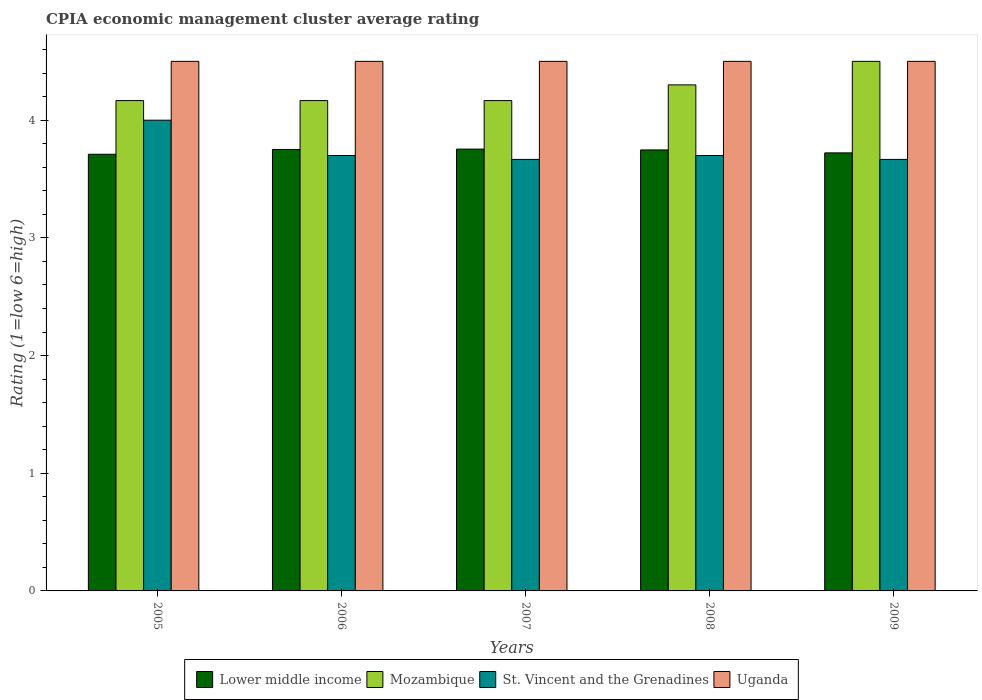How many groups of bars are there?
Your response must be concise. 5. Are the number of bars per tick equal to the number of legend labels?
Offer a terse response. Yes. How many bars are there on the 5th tick from the left?
Give a very brief answer. 4. How many bars are there on the 2nd tick from the right?
Provide a short and direct response. 4. In how many cases, is the number of bars for a given year not equal to the number of legend labels?
Make the answer very short. 0. What is the CPIA rating in Lower middle income in 2008?
Provide a succinct answer. 3.75. Across all years, what is the minimum CPIA rating in Mozambique?
Provide a succinct answer. 4.17. In which year was the CPIA rating in Mozambique maximum?
Give a very brief answer. 2009. In which year was the CPIA rating in St. Vincent and the Grenadines minimum?
Give a very brief answer. 2007. What is the total CPIA rating in St. Vincent and the Grenadines in the graph?
Provide a short and direct response. 18.73. What is the difference between the CPIA rating in Uganda in 2008 and that in 2009?
Provide a succinct answer. 0. What is the difference between the CPIA rating in St. Vincent and the Grenadines in 2008 and the CPIA rating in Mozambique in 2007?
Your response must be concise. -0.47. What is the average CPIA rating in St. Vincent and the Grenadines per year?
Provide a succinct answer. 3.75. In the year 2009, what is the difference between the CPIA rating in Lower middle income and CPIA rating in Mozambique?
Your answer should be very brief. -0.78. In how many years, is the CPIA rating in Uganda greater than 4.2?
Your answer should be compact. 5. What is the ratio of the CPIA rating in St. Vincent and the Grenadines in 2005 to that in 2006?
Give a very brief answer. 1.08. What is the difference between the highest and the second highest CPIA rating in St. Vincent and the Grenadines?
Offer a very short reply. 0.3. What is the difference between the highest and the lowest CPIA rating in St. Vincent and the Grenadines?
Your answer should be very brief. 0.33. In how many years, is the CPIA rating in Lower middle income greater than the average CPIA rating in Lower middle income taken over all years?
Keep it short and to the point. 3. Is the sum of the CPIA rating in St. Vincent and the Grenadines in 2007 and 2008 greater than the maximum CPIA rating in Uganda across all years?
Your answer should be compact. Yes. Is it the case that in every year, the sum of the CPIA rating in St. Vincent and the Grenadines and CPIA rating in Mozambique is greater than the sum of CPIA rating in Lower middle income and CPIA rating in Uganda?
Offer a very short reply. No. What does the 2nd bar from the left in 2007 represents?
Your answer should be very brief. Mozambique. What does the 4th bar from the right in 2008 represents?
Make the answer very short. Lower middle income. Are all the bars in the graph horizontal?
Offer a very short reply. No. What is the difference between two consecutive major ticks on the Y-axis?
Your answer should be very brief. 1. Does the graph contain any zero values?
Make the answer very short. No. How many legend labels are there?
Your answer should be very brief. 4. What is the title of the graph?
Ensure brevity in your answer.  CPIA economic management cluster average rating. What is the label or title of the Y-axis?
Offer a terse response. Rating (1=low 6=high). What is the Rating (1=low 6=high) in Lower middle income in 2005?
Your answer should be compact. 3.71. What is the Rating (1=low 6=high) of Mozambique in 2005?
Your response must be concise. 4.17. What is the Rating (1=low 6=high) of Uganda in 2005?
Give a very brief answer. 4.5. What is the Rating (1=low 6=high) of Lower middle income in 2006?
Your response must be concise. 3.75. What is the Rating (1=low 6=high) of Mozambique in 2006?
Give a very brief answer. 4.17. What is the Rating (1=low 6=high) of Lower middle income in 2007?
Provide a short and direct response. 3.75. What is the Rating (1=low 6=high) in Mozambique in 2007?
Make the answer very short. 4.17. What is the Rating (1=low 6=high) in St. Vincent and the Grenadines in 2007?
Offer a terse response. 3.67. What is the Rating (1=low 6=high) in Lower middle income in 2008?
Offer a terse response. 3.75. What is the Rating (1=low 6=high) in Lower middle income in 2009?
Provide a short and direct response. 3.72. What is the Rating (1=low 6=high) in Mozambique in 2009?
Your answer should be compact. 4.5. What is the Rating (1=low 6=high) in St. Vincent and the Grenadines in 2009?
Offer a very short reply. 3.67. What is the Rating (1=low 6=high) of Uganda in 2009?
Keep it short and to the point. 4.5. Across all years, what is the maximum Rating (1=low 6=high) in Lower middle income?
Make the answer very short. 3.75. Across all years, what is the maximum Rating (1=low 6=high) of St. Vincent and the Grenadines?
Your response must be concise. 4. Across all years, what is the maximum Rating (1=low 6=high) of Uganda?
Provide a succinct answer. 4.5. Across all years, what is the minimum Rating (1=low 6=high) of Lower middle income?
Ensure brevity in your answer.  3.71. Across all years, what is the minimum Rating (1=low 6=high) in Mozambique?
Offer a very short reply. 4.17. Across all years, what is the minimum Rating (1=low 6=high) of St. Vincent and the Grenadines?
Offer a very short reply. 3.67. Across all years, what is the minimum Rating (1=low 6=high) in Uganda?
Your answer should be compact. 4.5. What is the total Rating (1=low 6=high) of Lower middle income in the graph?
Provide a succinct answer. 18.69. What is the total Rating (1=low 6=high) in Mozambique in the graph?
Your answer should be very brief. 21.3. What is the total Rating (1=low 6=high) of St. Vincent and the Grenadines in the graph?
Your answer should be very brief. 18.73. What is the total Rating (1=low 6=high) in Uganda in the graph?
Provide a succinct answer. 22.5. What is the difference between the Rating (1=low 6=high) of Lower middle income in 2005 and that in 2006?
Ensure brevity in your answer.  -0.04. What is the difference between the Rating (1=low 6=high) in St. Vincent and the Grenadines in 2005 and that in 2006?
Your response must be concise. 0.3. What is the difference between the Rating (1=low 6=high) in Uganda in 2005 and that in 2006?
Offer a very short reply. 0. What is the difference between the Rating (1=low 6=high) of Lower middle income in 2005 and that in 2007?
Make the answer very short. -0.04. What is the difference between the Rating (1=low 6=high) of Uganda in 2005 and that in 2007?
Provide a short and direct response. 0. What is the difference between the Rating (1=low 6=high) in Lower middle income in 2005 and that in 2008?
Keep it short and to the point. -0.04. What is the difference between the Rating (1=low 6=high) in Mozambique in 2005 and that in 2008?
Your response must be concise. -0.13. What is the difference between the Rating (1=low 6=high) of St. Vincent and the Grenadines in 2005 and that in 2008?
Provide a short and direct response. 0.3. What is the difference between the Rating (1=low 6=high) in Uganda in 2005 and that in 2008?
Your response must be concise. 0. What is the difference between the Rating (1=low 6=high) in Lower middle income in 2005 and that in 2009?
Your answer should be very brief. -0.01. What is the difference between the Rating (1=low 6=high) in Mozambique in 2005 and that in 2009?
Give a very brief answer. -0.33. What is the difference between the Rating (1=low 6=high) in St. Vincent and the Grenadines in 2005 and that in 2009?
Provide a succinct answer. 0.33. What is the difference between the Rating (1=low 6=high) in Lower middle income in 2006 and that in 2007?
Make the answer very short. -0. What is the difference between the Rating (1=low 6=high) in Mozambique in 2006 and that in 2007?
Your response must be concise. 0. What is the difference between the Rating (1=low 6=high) of St. Vincent and the Grenadines in 2006 and that in 2007?
Provide a short and direct response. 0.03. What is the difference between the Rating (1=low 6=high) of Lower middle income in 2006 and that in 2008?
Offer a very short reply. 0. What is the difference between the Rating (1=low 6=high) of Mozambique in 2006 and that in 2008?
Offer a very short reply. -0.13. What is the difference between the Rating (1=low 6=high) of Uganda in 2006 and that in 2008?
Your answer should be very brief. 0. What is the difference between the Rating (1=low 6=high) in Lower middle income in 2006 and that in 2009?
Give a very brief answer. 0.03. What is the difference between the Rating (1=low 6=high) in Mozambique in 2006 and that in 2009?
Provide a succinct answer. -0.33. What is the difference between the Rating (1=low 6=high) in Uganda in 2006 and that in 2009?
Provide a succinct answer. 0. What is the difference between the Rating (1=low 6=high) in Lower middle income in 2007 and that in 2008?
Your answer should be compact. 0.01. What is the difference between the Rating (1=low 6=high) of Mozambique in 2007 and that in 2008?
Give a very brief answer. -0.13. What is the difference between the Rating (1=low 6=high) of St. Vincent and the Grenadines in 2007 and that in 2008?
Offer a terse response. -0.03. What is the difference between the Rating (1=low 6=high) in Lower middle income in 2007 and that in 2009?
Your answer should be very brief. 0.03. What is the difference between the Rating (1=low 6=high) of St. Vincent and the Grenadines in 2007 and that in 2009?
Your answer should be very brief. 0. What is the difference between the Rating (1=low 6=high) of Lower middle income in 2008 and that in 2009?
Provide a short and direct response. 0.03. What is the difference between the Rating (1=low 6=high) in Mozambique in 2008 and that in 2009?
Give a very brief answer. -0.2. What is the difference between the Rating (1=low 6=high) in Lower middle income in 2005 and the Rating (1=low 6=high) in Mozambique in 2006?
Provide a short and direct response. -0.46. What is the difference between the Rating (1=low 6=high) in Lower middle income in 2005 and the Rating (1=low 6=high) in St. Vincent and the Grenadines in 2006?
Provide a succinct answer. 0.01. What is the difference between the Rating (1=low 6=high) of Lower middle income in 2005 and the Rating (1=low 6=high) of Uganda in 2006?
Give a very brief answer. -0.79. What is the difference between the Rating (1=low 6=high) of Mozambique in 2005 and the Rating (1=low 6=high) of St. Vincent and the Grenadines in 2006?
Ensure brevity in your answer.  0.47. What is the difference between the Rating (1=low 6=high) in Mozambique in 2005 and the Rating (1=low 6=high) in Uganda in 2006?
Ensure brevity in your answer.  -0.33. What is the difference between the Rating (1=low 6=high) of St. Vincent and the Grenadines in 2005 and the Rating (1=low 6=high) of Uganda in 2006?
Offer a very short reply. -0.5. What is the difference between the Rating (1=low 6=high) of Lower middle income in 2005 and the Rating (1=low 6=high) of Mozambique in 2007?
Offer a very short reply. -0.46. What is the difference between the Rating (1=low 6=high) of Lower middle income in 2005 and the Rating (1=low 6=high) of St. Vincent and the Grenadines in 2007?
Make the answer very short. 0.04. What is the difference between the Rating (1=low 6=high) in Lower middle income in 2005 and the Rating (1=low 6=high) in Uganda in 2007?
Your response must be concise. -0.79. What is the difference between the Rating (1=low 6=high) in Mozambique in 2005 and the Rating (1=low 6=high) in St. Vincent and the Grenadines in 2007?
Provide a succinct answer. 0.5. What is the difference between the Rating (1=low 6=high) in Mozambique in 2005 and the Rating (1=low 6=high) in Uganda in 2007?
Make the answer very short. -0.33. What is the difference between the Rating (1=low 6=high) of St. Vincent and the Grenadines in 2005 and the Rating (1=low 6=high) of Uganda in 2007?
Ensure brevity in your answer.  -0.5. What is the difference between the Rating (1=low 6=high) of Lower middle income in 2005 and the Rating (1=low 6=high) of Mozambique in 2008?
Ensure brevity in your answer.  -0.59. What is the difference between the Rating (1=low 6=high) of Lower middle income in 2005 and the Rating (1=low 6=high) of St. Vincent and the Grenadines in 2008?
Your answer should be compact. 0.01. What is the difference between the Rating (1=low 6=high) of Lower middle income in 2005 and the Rating (1=low 6=high) of Uganda in 2008?
Your answer should be compact. -0.79. What is the difference between the Rating (1=low 6=high) of Mozambique in 2005 and the Rating (1=low 6=high) of St. Vincent and the Grenadines in 2008?
Your response must be concise. 0.47. What is the difference between the Rating (1=low 6=high) in Mozambique in 2005 and the Rating (1=low 6=high) in Uganda in 2008?
Offer a terse response. -0.33. What is the difference between the Rating (1=low 6=high) of St. Vincent and the Grenadines in 2005 and the Rating (1=low 6=high) of Uganda in 2008?
Ensure brevity in your answer.  -0.5. What is the difference between the Rating (1=low 6=high) of Lower middle income in 2005 and the Rating (1=low 6=high) of Mozambique in 2009?
Your response must be concise. -0.79. What is the difference between the Rating (1=low 6=high) in Lower middle income in 2005 and the Rating (1=low 6=high) in St. Vincent and the Grenadines in 2009?
Ensure brevity in your answer.  0.04. What is the difference between the Rating (1=low 6=high) of Lower middle income in 2005 and the Rating (1=low 6=high) of Uganda in 2009?
Your response must be concise. -0.79. What is the difference between the Rating (1=low 6=high) of Mozambique in 2005 and the Rating (1=low 6=high) of St. Vincent and the Grenadines in 2009?
Offer a terse response. 0.5. What is the difference between the Rating (1=low 6=high) in Lower middle income in 2006 and the Rating (1=low 6=high) in Mozambique in 2007?
Ensure brevity in your answer.  -0.42. What is the difference between the Rating (1=low 6=high) of Lower middle income in 2006 and the Rating (1=low 6=high) of St. Vincent and the Grenadines in 2007?
Your answer should be compact. 0.08. What is the difference between the Rating (1=low 6=high) of Lower middle income in 2006 and the Rating (1=low 6=high) of Uganda in 2007?
Provide a short and direct response. -0.75. What is the difference between the Rating (1=low 6=high) in Lower middle income in 2006 and the Rating (1=low 6=high) in Mozambique in 2008?
Provide a succinct answer. -0.55. What is the difference between the Rating (1=low 6=high) of Lower middle income in 2006 and the Rating (1=low 6=high) of St. Vincent and the Grenadines in 2008?
Give a very brief answer. 0.05. What is the difference between the Rating (1=low 6=high) in Lower middle income in 2006 and the Rating (1=low 6=high) in Uganda in 2008?
Provide a succinct answer. -0.75. What is the difference between the Rating (1=low 6=high) of Mozambique in 2006 and the Rating (1=low 6=high) of St. Vincent and the Grenadines in 2008?
Your answer should be very brief. 0.47. What is the difference between the Rating (1=low 6=high) in Mozambique in 2006 and the Rating (1=low 6=high) in Uganda in 2008?
Your answer should be compact. -0.33. What is the difference between the Rating (1=low 6=high) in St. Vincent and the Grenadines in 2006 and the Rating (1=low 6=high) in Uganda in 2008?
Your response must be concise. -0.8. What is the difference between the Rating (1=low 6=high) of Lower middle income in 2006 and the Rating (1=low 6=high) of Mozambique in 2009?
Give a very brief answer. -0.75. What is the difference between the Rating (1=low 6=high) in Lower middle income in 2006 and the Rating (1=low 6=high) in St. Vincent and the Grenadines in 2009?
Offer a terse response. 0.08. What is the difference between the Rating (1=low 6=high) of Lower middle income in 2006 and the Rating (1=low 6=high) of Uganda in 2009?
Your answer should be compact. -0.75. What is the difference between the Rating (1=low 6=high) of Mozambique in 2006 and the Rating (1=low 6=high) of St. Vincent and the Grenadines in 2009?
Offer a terse response. 0.5. What is the difference between the Rating (1=low 6=high) of Mozambique in 2006 and the Rating (1=low 6=high) of Uganda in 2009?
Give a very brief answer. -0.33. What is the difference between the Rating (1=low 6=high) of St. Vincent and the Grenadines in 2006 and the Rating (1=low 6=high) of Uganda in 2009?
Your answer should be compact. -0.8. What is the difference between the Rating (1=low 6=high) of Lower middle income in 2007 and the Rating (1=low 6=high) of Mozambique in 2008?
Make the answer very short. -0.55. What is the difference between the Rating (1=low 6=high) of Lower middle income in 2007 and the Rating (1=low 6=high) of St. Vincent and the Grenadines in 2008?
Provide a short and direct response. 0.05. What is the difference between the Rating (1=low 6=high) in Lower middle income in 2007 and the Rating (1=low 6=high) in Uganda in 2008?
Provide a short and direct response. -0.75. What is the difference between the Rating (1=low 6=high) of Mozambique in 2007 and the Rating (1=low 6=high) of St. Vincent and the Grenadines in 2008?
Give a very brief answer. 0.47. What is the difference between the Rating (1=low 6=high) in Lower middle income in 2007 and the Rating (1=low 6=high) in Mozambique in 2009?
Give a very brief answer. -0.75. What is the difference between the Rating (1=low 6=high) of Lower middle income in 2007 and the Rating (1=low 6=high) of St. Vincent and the Grenadines in 2009?
Keep it short and to the point. 0.09. What is the difference between the Rating (1=low 6=high) of Lower middle income in 2007 and the Rating (1=low 6=high) of Uganda in 2009?
Provide a succinct answer. -0.75. What is the difference between the Rating (1=low 6=high) of Mozambique in 2007 and the Rating (1=low 6=high) of Uganda in 2009?
Ensure brevity in your answer.  -0.33. What is the difference between the Rating (1=low 6=high) in St. Vincent and the Grenadines in 2007 and the Rating (1=low 6=high) in Uganda in 2009?
Keep it short and to the point. -0.83. What is the difference between the Rating (1=low 6=high) in Lower middle income in 2008 and the Rating (1=low 6=high) in Mozambique in 2009?
Your answer should be very brief. -0.75. What is the difference between the Rating (1=low 6=high) of Lower middle income in 2008 and the Rating (1=low 6=high) of St. Vincent and the Grenadines in 2009?
Provide a succinct answer. 0.08. What is the difference between the Rating (1=low 6=high) in Lower middle income in 2008 and the Rating (1=low 6=high) in Uganda in 2009?
Your response must be concise. -0.75. What is the difference between the Rating (1=low 6=high) in Mozambique in 2008 and the Rating (1=low 6=high) in St. Vincent and the Grenadines in 2009?
Keep it short and to the point. 0.63. What is the difference between the Rating (1=low 6=high) in Mozambique in 2008 and the Rating (1=low 6=high) in Uganda in 2009?
Offer a terse response. -0.2. What is the difference between the Rating (1=low 6=high) of St. Vincent and the Grenadines in 2008 and the Rating (1=low 6=high) of Uganda in 2009?
Offer a terse response. -0.8. What is the average Rating (1=low 6=high) of Lower middle income per year?
Your response must be concise. 3.74. What is the average Rating (1=low 6=high) in Mozambique per year?
Offer a very short reply. 4.26. What is the average Rating (1=low 6=high) of St. Vincent and the Grenadines per year?
Make the answer very short. 3.75. In the year 2005, what is the difference between the Rating (1=low 6=high) in Lower middle income and Rating (1=low 6=high) in Mozambique?
Offer a terse response. -0.46. In the year 2005, what is the difference between the Rating (1=low 6=high) of Lower middle income and Rating (1=low 6=high) of St. Vincent and the Grenadines?
Ensure brevity in your answer.  -0.29. In the year 2005, what is the difference between the Rating (1=low 6=high) of Lower middle income and Rating (1=low 6=high) of Uganda?
Keep it short and to the point. -0.79. In the year 2005, what is the difference between the Rating (1=low 6=high) of Mozambique and Rating (1=low 6=high) of St. Vincent and the Grenadines?
Your answer should be very brief. 0.17. In the year 2006, what is the difference between the Rating (1=low 6=high) in Lower middle income and Rating (1=low 6=high) in Mozambique?
Ensure brevity in your answer.  -0.42. In the year 2006, what is the difference between the Rating (1=low 6=high) of Lower middle income and Rating (1=low 6=high) of St. Vincent and the Grenadines?
Your answer should be compact. 0.05. In the year 2006, what is the difference between the Rating (1=low 6=high) in Lower middle income and Rating (1=low 6=high) in Uganda?
Give a very brief answer. -0.75. In the year 2006, what is the difference between the Rating (1=low 6=high) in Mozambique and Rating (1=low 6=high) in St. Vincent and the Grenadines?
Make the answer very short. 0.47. In the year 2006, what is the difference between the Rating (1=low 6=high) in Mozambique and Rating (1=low 6=high) in Uganda?
Your answer should be very brief. -0.33. In the year 2006, what is the difference between the Rating (1=low 6=high) of St. Vincent and the Grenadines and Rating (1=low 6=high) of Uganda?
Provide a short and direct response. -0.8. In the year 2007, what is the difference between the Rating (1=low 6=high) of Lower middle income and Rating (1=low 6=high) of Mozambique?
Provide a succinct answer. -0.41. In the year 2007, what is the difference between the Rating (1=low 6=high) in Lower middle income and Rating (1=low 6=high) in St. Vincent and the Grenadines?
Give a very brief answer. 0.09. In the year 2007, what is the difference between the Rating (1=low 6=high) in Lower middle income and Rating (1=low 6=high) in Uganda?
Keep it short and to the point. -0.75. In the year 2008, what is the difference between the Rating (1=low 6=high) in Lower middle income and Rating (1=low 6=high) in Mozambique?
Ensure brevity in your answer.  -0.55. In the year 2008, what is the difference between the Rating (1=low 6=high) of Lower middle income and Rating (1=low 6=high) of St. Vincent and the Grenadines?
Your answer should be compact. 0.05. In the year 2008, what is the difference between the Rating (1=low 6=high) in Lower middle income and Rating (1=low 6=high) in Uganda?
Ensure brevity in your answer.  -0.75. In the year 2008, what is the difference between the Rating (1=low 6=high) of Mozambique and Rating (1=low 6=high) of St. Vincent and the Grenadines?
Ensure brevity in your answer.  0.6. In the year 2008, what is the difference between the Rating (1=low 6=high) of Mozambique and Rating (1=low 6=high) of Uganda?
Offer a very short reply. -0.2. In the year 2009, what is the difference between the Rating (1=low 6=high) in Lower middle income and Rating (1=low 6=high) in Mozambique?
Keep it short and to the point. -0.78. In the year 2009, what is the difference between the Rating (1=low 6=high) in Lower middle income and Rating (1=low 6=high) in St. Vincent and the Grenadines?
Your answer should be compact. 0.06. In the year 2009, what is the difference between the Rating (1=low 6=high) of Lower middle income and Rating (1=low 6=high) of Uganda?
Provide a succinct answer. -0.78. In the year 2009, what is the difference between the Rating (1=low 6=high) of Mozambique and Rating (1=low 6=high) of St. Vincent and the Grenadines?
Keep it short and to the point. 0.83. In the year 2009, what is the difference between the Rating (1=low 6=high) of Mozambique and Rating (1=low 6=high) of Uganda?
Ensure brevity in your answer.  0. In the year 2009, what is the difference between the Rating (1=low 6=high) in St. Vincent and the Grenadines and Rating (1=low 6=high) in Uganda?
Your answer should be compact. -0.83. What is the ratio of the Rating (1=low 6=high) of Lower middle income in 2005 to that in 2006?
Offer a terse response. 0.99. What is the ratio of the Rating (1=low 6=high) of St. Vincent and the Grenadines in 2005 to that in 2006?
Offer a very short reply. 1.08. What is the ratio of the Rating (1=low 6=high) of Uganda in 2005 to that in 2006?
Give a very brief answer. 1. What is the ratio of the Rating (1=low 6=high) in Lower middle income in 2005 to that in 2007?
Ensure brevity in your answer.  0.99. What is the ratio of the Rating (1=low 6=high) in St. Vincent and the Grenadines in 2005 to that in 2007?
Offer a very short reply. 1.09. What is the ratio of the Rating (1=low 6=high) of Lower middle income in 2005 to that in 2008?
Your answer should be compact. 0.99. What is the ratio of the Rating (1=low 6=high) in Mozambique in 2005 to that in 2008?
Your response must be concise. 0.97. What is the ratio of the Rating (1=low 6=high) of St. Vincent and the Grenadines in 2005 to that in 2008?
Offer a very short reply. 1.08. What is the ratio of the Rating (1=low 6=high) of Uganda in 2005 to that in 2008?
Keep it short and to the point. 1. What is the ratio of the Rating (1=low 6=high) in Lower middle income in 2005 to that in 2009?
Provide a succinct answer. 1. What is the ratio of the Rating (1=low 6=high) in Mozambique in 2005 to that in 2009?
Offer a very short reply. 0.93. What is the ratio of the Rating (1=low 6=high) of Uganda in 2005 to that in 2009?
Your response must be concise. 1. What is the ratio of the Rating (1=low 6=high) in Lower middle income in 2006 to that in 2007?
Ensure brevity in your answer.  1. What is the ratio of the Rating (1=low 6=high) of St. Vincent and the Grenadines in 2006 to that in 2007?
Make the answer very short. 1.01. What is the ratio of the Rating (1=low 6=high) in Uganda in 2006 to that in 2007?
Offer a terse response. 1. What is the ratio of the Rating (1=low 6=high) in Lower middle income in 2006 to that in 2008?
Ensure brevity in your answer.  1. What is the ratio of the Rating (1=low 6=high) in Mozambique in 2006 to that in 2008?
Give a very brief answer. 0.97. What is the ratio of the Rating (1=low 6=high) of St. Vincent and the Grenadines in 2006 to that in 2008?
Offer a very short reply. 1. What is the ratio of the Rating (1=low 6=high) in Mozambique in 2006 to that in 2009?
Your answer should be very brief. 0.93. What is the ratio of the Rating (1=low 6=high) in St. Vincent and the Grenadines in 2006 to that in 2009?
Your answer should be compact. 1.01. What is the ratio of the Rating (1=low 6=high) of Lower middle income in 2007 to that in 2008?
Your answer should be compact. 1. What is the ratio of the Rating (1=low 6=high) in Mozambique in 2007 to that in 2008?
Make the answer very short. 0.97. What is the ratio of the Rating (1=low 6=high) of Lower middle income in 2007 to that in 2009?
Give a very brief answer. 1.01. What is the ratio of the Rating (1=low 6=high) in Mozambique in 2007 to that in 2009?
Your answer should be very brief. 0.93. What is the ratio of the Rating (1=low 6=high) in Uganda in 2007 to that in 2009?
Offer a terse response. 1. What is the ratio of the Rating (1=low 6=high) of Lower middle income in 2008 to that in 2009?
Your response must be concise. 1.01. What is the ratio of the Rating (1=low 6=high) in Mozambique in 2008 to that in 2009?
Provide a succinct answer. 0.96. What is the ratio of the Rating (1=low 6=high) of St. Vincent and the Grenadines in 2008 to that in 2009?
Ensure brevity in your answer.  1.01. What is the ratio of the Rating (1=low 6=high) of Uganda in 2008 to that in 2009?
Your response must be concise. 1. What is the difference between the highest and the second highest Rating (1=low 6=high) in Lower middle income?
Offer a terse response. 0. What is the difference between the highest and the second highest Rating (1=low 6=high) in Mozambique?
Your response must be concise. 0.2. What is the difference between the highest and the lowest Rating (1=low 6=high) in Lower middle income?
Provide a short and direct response. 0.04. What is the difference between the highest and the lowest Rating (1=low 6=high) in St. Vincent and the Grenadines?
Your response must be concise. 0.33. What is the difference between the highest and the lowest Rating (1=low 6=high) of Uganda?
Provide a short and direct response. 0. 